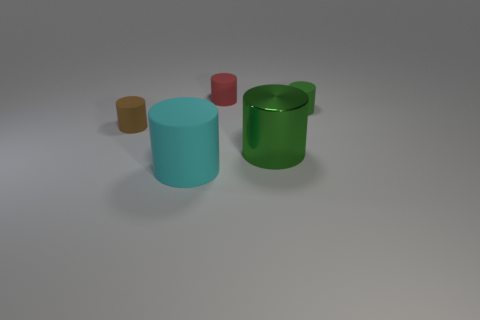The large rubber cylinder has what color?
Your answer should be compact. Cyan. Does the shiny cylinder have the same color as the tiny cylinder on the right side of the red rubber cylinder?
Make the answer very short. Yes. There is a green cylinder that is the same material as the red cylinder; what is its size?
Your answer should be compact. Small. Are there any rubber cylinders that have the same color as the large shiny object?
Give a very brief answer. Yes. What number of objects are either green things that are on the right side of the large green metallic object or big purple metal cubes?
Give a very brief answer. 1. Is the material of the large cyan thing the same as the tiny object that is left of the red object?
Provide a short and direct response. Yes. Is there a blue sphere that has the same material as the big green thing?
Your answer should be compact. No. How many things are tiny objects on the right side of the small brown rubber thing or red objects that are behind the green shiny cylinder?
Your response must be concise. 2. How many other objects are there of the same shape as the large metallic object?
Offer a very short reply. 4. How many objects are small brown matte cubes or big cylinders?
Your answer should be compact. 2. 